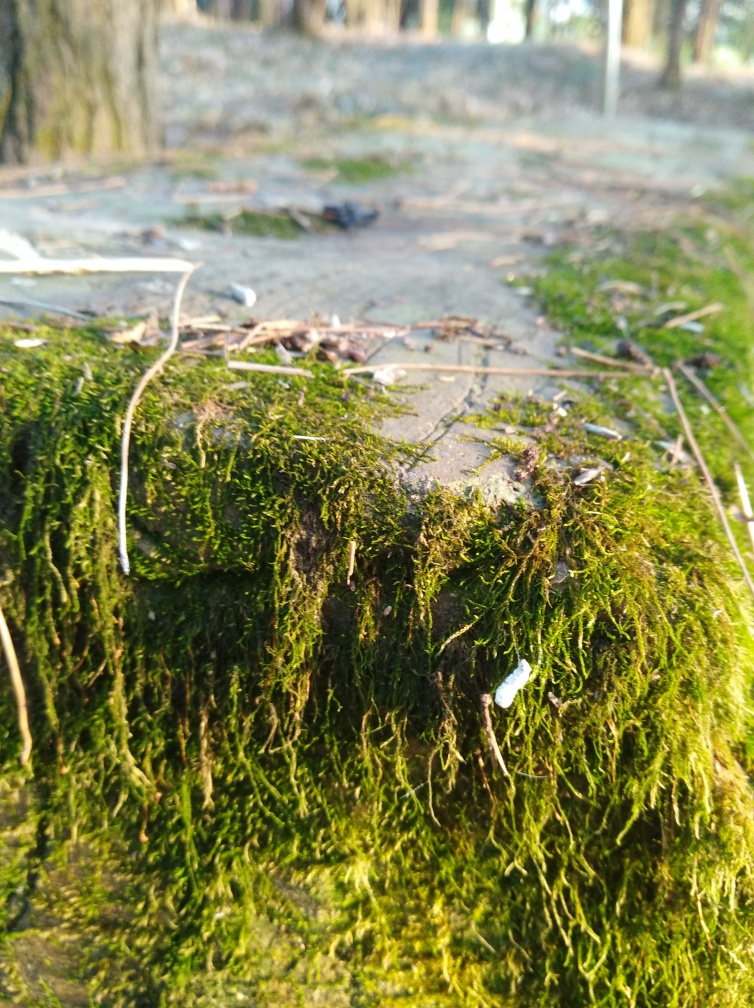Are the texture details of distant houses and the ground lost?
 Yes 